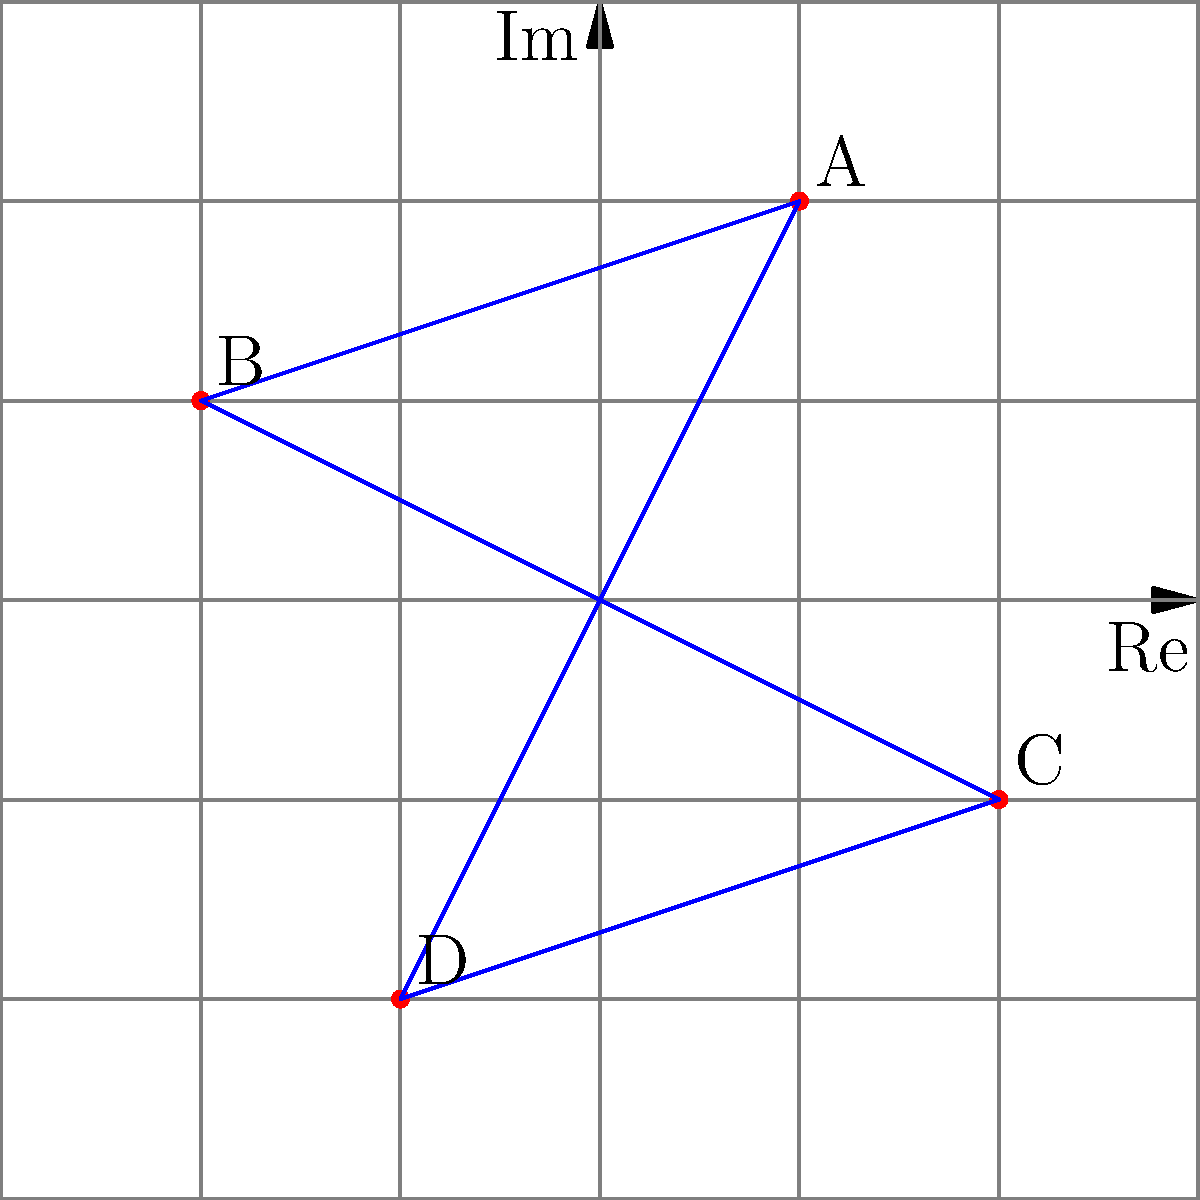In a coordinate system based on complex numbers, four stars in a constellation are mapped as follows: A at $1+2i$, B at $-2+i$, C at $2-i$, and D at $-1-2i$. If we connect these stars to form a quadrilateral, what is the area of this quadrilateral in square units? To find the area of the quadrilateral formed by these stars, we can use the following steps:

1) First, we need to recall the formula for the area of a quadrilateral given the coordinates of its vertices in the complex plane. If the vertices are $z_1$, $z_2$, $z_3$, and $z_4$ in counterclockwise order, the area is given by:

   $$ \text{Area} = \frac{1}{2}|\text{Im}(z_1\overline{z_2} + z_2\overline{z_3} + z_3\overline{z_4} + z_4\overline{z_1})|$$

   where $\text{Im}$ denotes the imaginary part and $\overline{z}$ is the complex conjugate of $z$.

2) In our case:
   $z_1 = 1+2i$ (A)
   $z_2 = -2+i$ (B)
   $z_3 = 2-i$ (C)
   $z_4 = -1-2i$ (D)

3) Let's calculate each term inside the imaginary part:

   $z_1\overline{z_2} = (1+2i)(-2-i) = -2-i-4i-2i^2 = -4+3i$
   $z_2\overline{z_3} = (-2+i)(2+i) = -4-2i+2i+i^2 = -5-i$
   $z_3\overline{z_4} = (2-i)(-1+2i) = -2+4i+i-2i^2 = 2+5i$
   $z_4\overline{z_1} = (-1-2i)(1-2i) = -1+2i-2i+4i^2 = -5+4i$

4) Sum these up:
   $(-4+3i) + (-5-i) + (2+5i) + (-5+4i) = -12+11i$

5) Take the imaginary part:
   $\text{Im}(-12+11i) = 11$

6) Multiply by 1/2:
   $\frac{1}{2} \cdot 11 = 5.5$

Therefore, the area of the quadrilateral is 5.5 square units.
Answer: 5.5 square units 